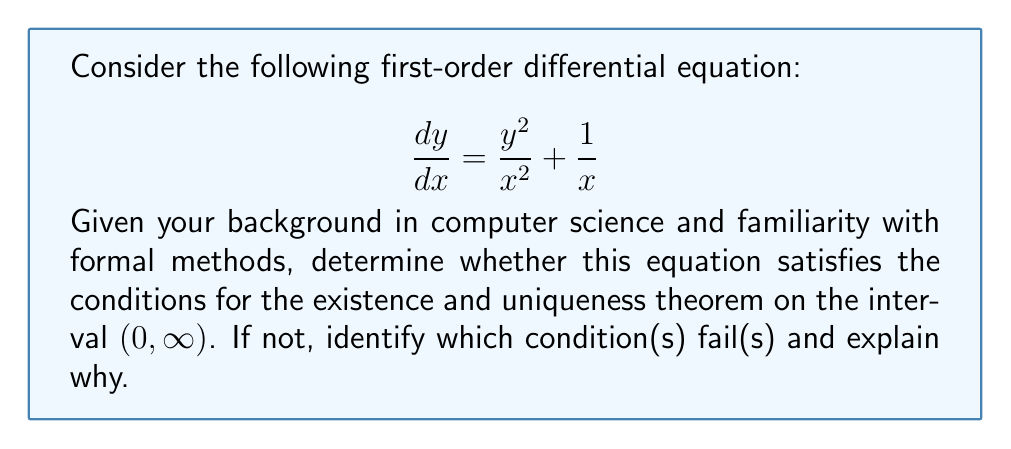Could you help me with this problem? To determine the existence and uniqueness of solutions, we need to check if the equation satisfies the conditions of the Existence and Uniqueness Theorem for first-order differential equations. The theorem states that a unique solution exists if:

1. $f(x,y)$ is continuous on some rectangle containing the initial point.
2. $\frac{\partial f}{\partial y}$ exists and is continuous on the same rectangle.

Let's examine our equation:

$$ \frac{dy}{dx} = f(x,y) = \frac{y^2}{x^2} + \frac{1}{x} $$

Step 1: Check continuity of $f(x,y)$
$f(x,y)$ is continuous for all $x \neq 0$ and all $y$. On the interval $(0, \infty)$, $f(x,y)$ is continuous.

Step 2: Check existence and continuity of $\frac{\partial f}{\partial y}$
$$ \frac{\partial f}{\partial y} = \frac{\partial}{\partial y}\left(\frac{y^2}{x^2} + \frac{1}{x}\right) = \frac{2y}{x^2} $$

$\frac{\partial f}{\partial y}$ exists and is continuous for all $x \neq 0$ and all $y$. On the interval $(0, \infty)$, $\frac{\partial f}{\partial y}$ is continuous.

Step 3: Conclusion
Both conditions of the Existence and Uniqueness Theorem are satisfied on the interval $(0, \infty)$. Therefore, for any initial condition $(x_0, y_0)$ where $x_0 > 0$, there exists a unique solution to the differential equation in some neighborhood of $x_0$.

It's worth noting that the equation fails to satisfy these conditions at $x = 0$, which is consistent with the given interval $(0, \infty)$.
Answer: The equation satisfies the Existence and Uniqueness Theorem on $(0, \infty)$. 